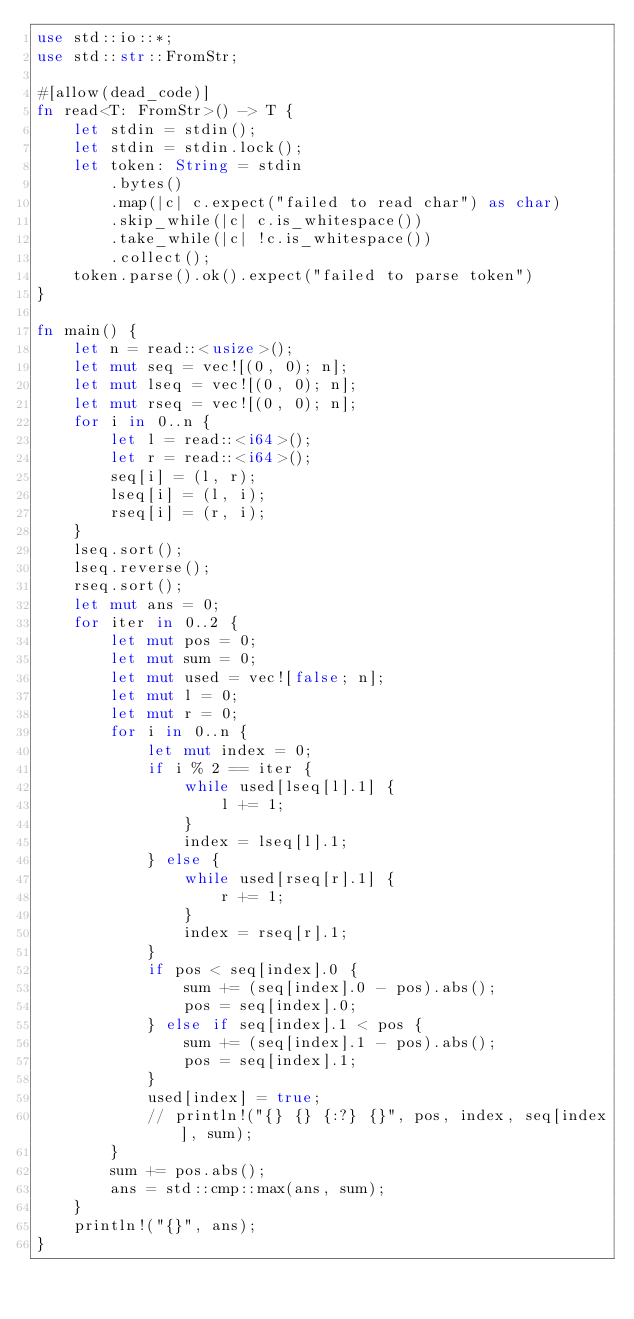<code> <loc_0><loc_0><loc_500><loc_500><_Rust_>use std::io::*;
use std::str::FromStr;

#[allow(dead_code)]
fn read<T: FromStr>() -> T {
    let stdin = stdin();
    let stdin = stdin.lock();
    let token: String = stdin
        .bytes()
        .map(|c| c.expect("failed to read char") as char)
        .skip_while(|c| c.is_whitespace())
        .take_while(|c| !c.is_whitespace())
        .collect();
    token.parse().ok().expect("failed to parse token")
}

fn main() {
    let n = read::<usize>();
    let mut seq = vec![(0, 0); n];
    let mut lseq = vec![(0, 0); n];
    let mut rseq = vec![(0, 0); n];
    for i in 0..n {
        let l = read::<i64>();
        let r = read::<i64>();
        seq[i] = (l, r);
        lseq[i] = (l, i);
        rseq[i] = (r, i);
    }
    lseq.sort();
    lseq.reverse();
    rseq.sort();
    let mut ans = 0;
    for iter in 0..2 {
        let mut pos = 0;
        let mut sum = 0;
        let mut used = vec![false; n];
        let mut l = 0;
        let mut r = 0;
        for i in 0..n {
            let mut index = 0;
            if i % 2 == iter {
                while used[lseq[l].1] {
                    l += 1;
                }
                index = lseq[l].1;
            } else {
                while used[rseq[r].1] {
                    r += 1;
                }
                index = rseq[r].1;
            }
            if pos < seq[index].0 {
                sum += (seq[index].0 - pos).abs();
                pos = seq[index].0;
            } else if seq[index].1 < pos {
                sum += (seq[index].1 - pos).abs();
                pos = seq[index].1;
            }
            used[index] = true;
            // println!("{} {} {:?} {}", pos, index, seq[index], sum);
        }
        sum += pos.abs();
        ans = std::cmp::max(ans, sum);
    }
    println!("{}", ans);
}
</code> 